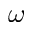<formula> <loc_0><loc_0><loc_500><loc_500>\omega</formula> 